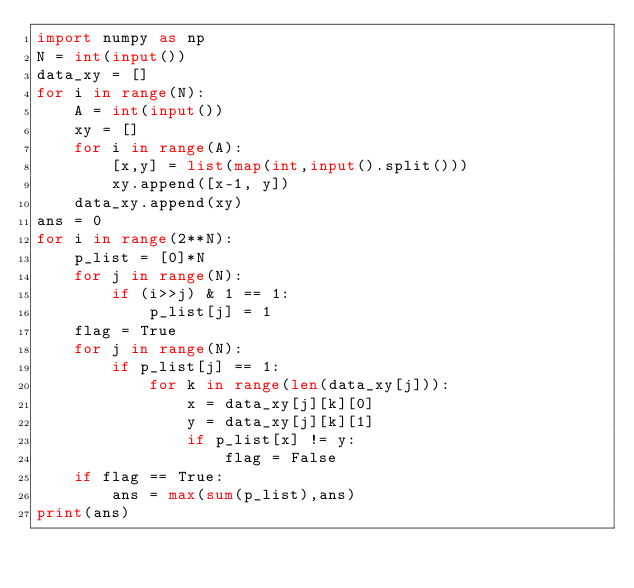<code> <loc_0><loc_0><loc_500><loc_500><_Python_>import numpy as np
N = int(input())
data_xy = []
for i in range(N):
    A = int(input())
    xy = []
    for i in range(A):
        [x,y] = list(map(int,input().split()))
        xy.append([x-1, y])
    data_xy.append(xy)
ans = 0
for i in range(2**N):
    p_list = [0]*N
    for j in range(N):
        if (i>>j) & 1 == 1:
            p_list[j] = 1
    flag = True
    for j in range(N):
        if p_list[j] == 1:
            for k in range(len(data_xy[j])):
                x = data_xy[j][k][0]
                y = data_xy[j][k][1]
                if p_list[x] != y:
                    flag = False
    if flag == True:
        ans = max(sum(p_list),ans)
print(ans)</code> 